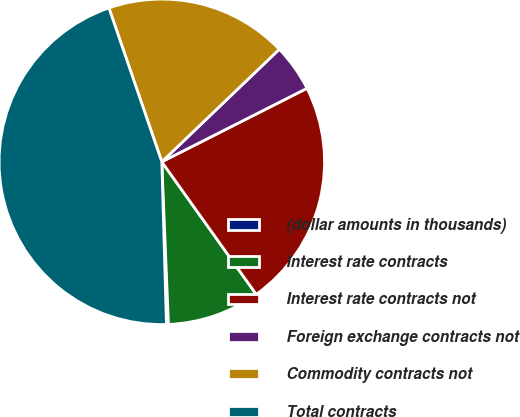Convert chart. <chart><loc_0><loc_0><loc_500><loc_500><pie_chart><fcel>(dollar amounts in thousands)<fcel>Interest rate contracts<fcel>Interest rate contracts not<fcel>Foreign exchange contracts not<fcel>Commodity contracts not<fcel>Total contracts<nl><fcel>0.2%<fcel>9.2%<fcel>22.61%<fcel>4.7%<fcel>18.11%<fcel>45.19%<nl></chart> 